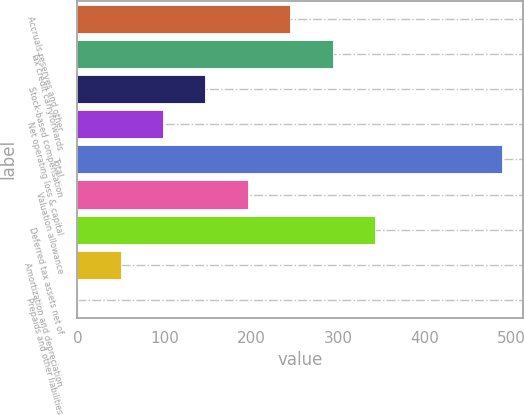<chart> <loc_0><loc_0><loc_500><loc_500><bar_chart><fcel>Accruals reserves and other<fcel>Tax credit carryforwards<fcel>Stock-based compensation<fcel>Net operating loss & capital<fcel>Total<fcel>Valuation allowance<fcel>Deferred tax assets net of<fcel>Amortization and depreciation<fcel>Prepaids and other liabilities<nl><fcel>245<fcel>293.8<fcel>147.4<fcel>98.6<fcel>489<fcel>196.2<fcel>342.6<fcel>49.8<fcel>1<nl></chart> 